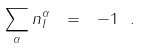Convert formula to latex. <formula><loc_0><loc_0><loc_500><loc_500>\sum _ { \alpha } n _ { I } ^ { \alpha } \ = \ - 1 \ .</formula> 